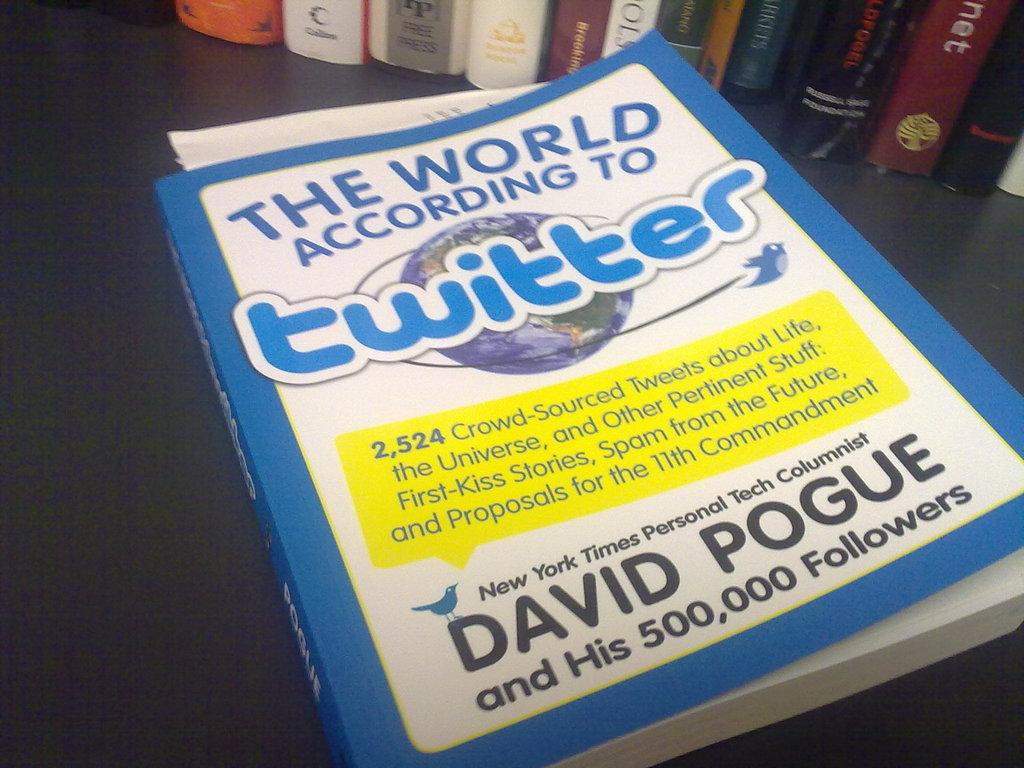<image>
Create a compact narrative representing the image presented. the name David is on the Twitter book 